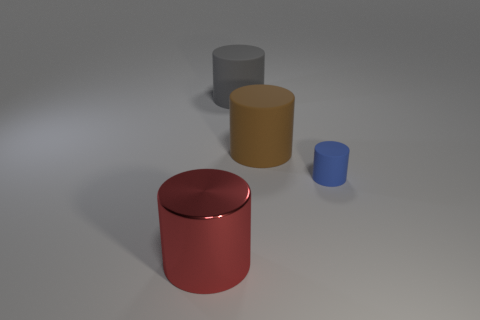Subtract 1 cylinders. How many cylinders are left? 3 Subtract all green cylinders. Subtract all purple cubes. How many cylinders are left? 4 Add 4 yellow shiny cylinders. How many objects exist? 8 Add 1 big things. How many big things exist? 4 Subtract 0 green cylinders. How many objects are left? 4 Subtract all tiny cylinders. Subtract all large gray cylinders. How many objects are left? 2 Add 3 cylinders. How many cylinders are left? 7 